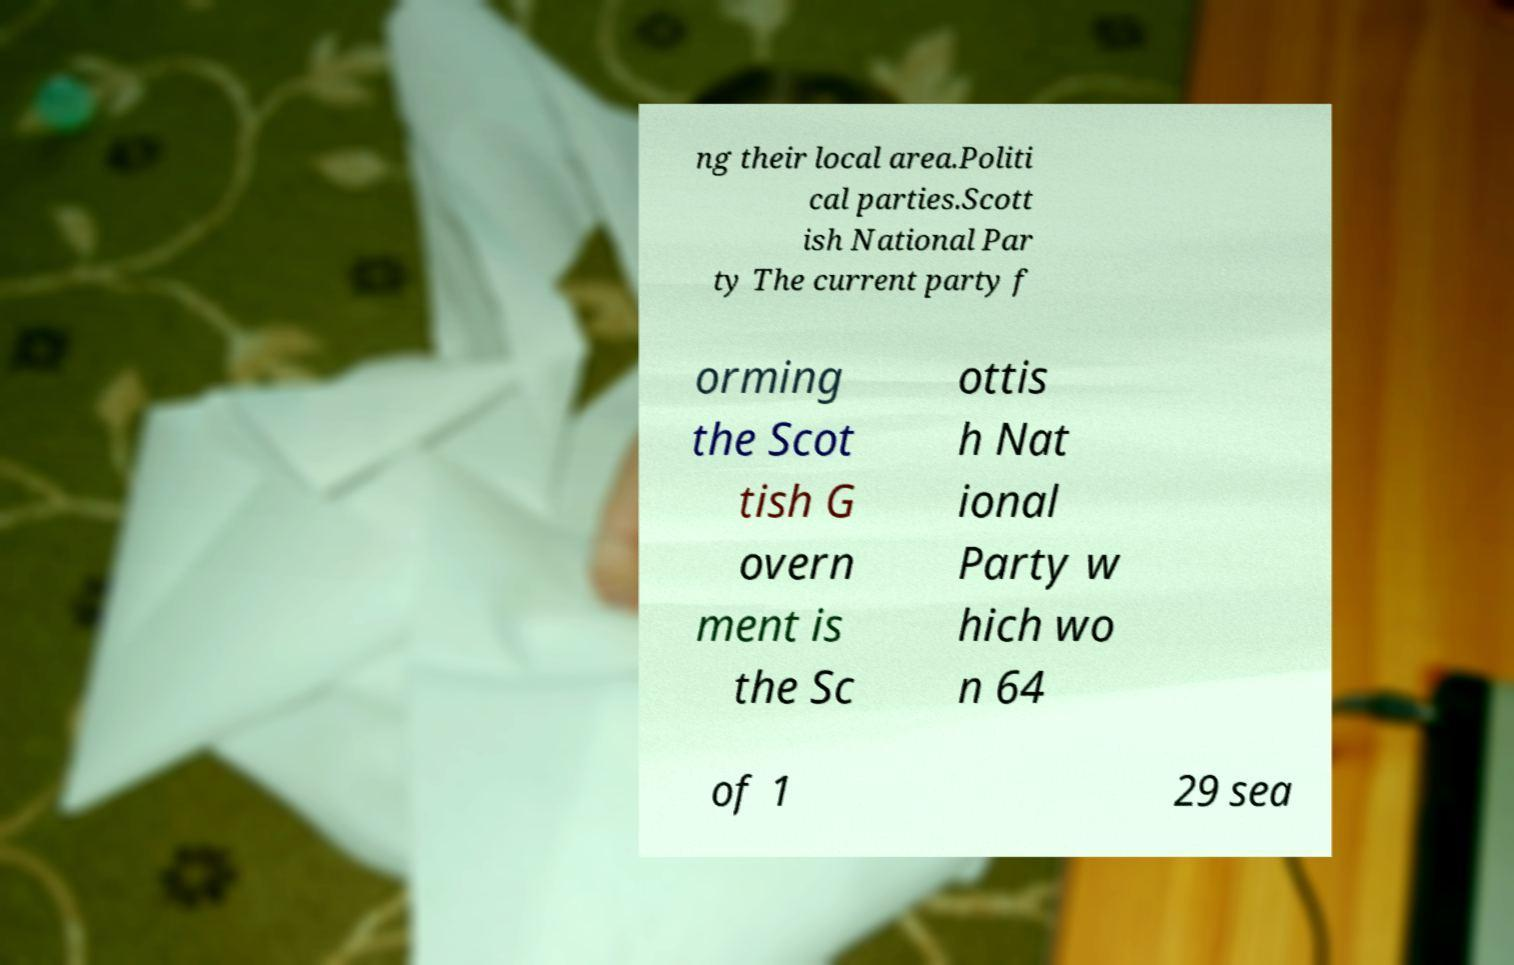Can you accurately transcribe the text from the provided image for me? ng their local area.Politi cal parties.Scott ish National Par ty The current party f orming the Scot tish G overn ment is the Sc ottis h Nat ional Party w hich wo n 64 of 1 29 sea 